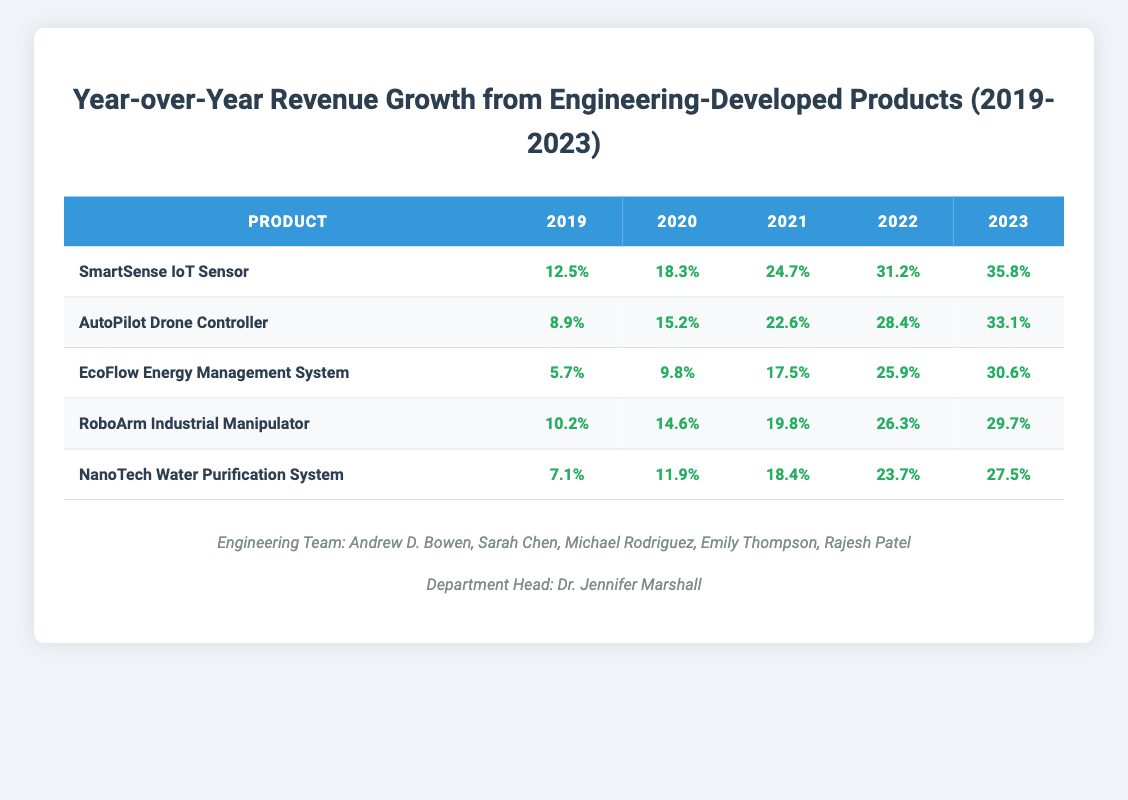What was the revenue growth percentage for the SmartSense IoT Sensor in 2021? According to the table, for the SmartSense IoT Sensor, the revenue growth percentage for the year 2021 is directly listed as 24.7% in the corresponding cell.
Answer: 24.7% Which product had the highest revenue growth in 2023? In 2023, the growth percentages for each product are: SmartSense IoT Sensor (35.8%), AutoPilot Drone Controller (33.1%), EcoFlow Energy Management System (30.6%), RoboArm Industrial Manipulator (29.7%), and NanoTech Water Purification System (27.5%). The highest value is 35.8% for the SmartSense IoT Sensor.
Answer: SmartSense IoT Sensor What is the average revenue growth for the EcoFlow Energy Management System over the years? The growth percentages for EcoFlow Energy Management System from 2019 to 2023 are 5.7%, 9.8%, 17.5%, 25.9%, and 30.6%. Adding these gives a total of 89.5%. Since there are 5 years, the average is 89.5% / 5 = 17.9%.
Answer: 17.9% Did the revenue growth for the NanoTech Water Purification System increase every year? By looking at the percentage values for the NanoTech Water Purification System, which are 7.1%, 11.9%, 18.4%, 23.7%, and 27.5%, it is evident that each subsequent year shows a higher percentage than the previous one, indicating consistent annual growth.
Answer: Yes In which year did the AutoPilot Drone Controller see the largest increase in revenue growth compared to the previous year? For the AutoPilot Drone Controller, the growth percentages are: 8.9% in 2019, 15.2% in 2020 (increase of 6.3%), 22.6% in 2021 (increase of 7.4%), 28.4% in 2022 (increase of 5.8%), and 33.1% in 2023 (increase of 4.7%). The largest increase occurred in 2021 with an increase of 7.4% from the previous year.
Answer: 2021 